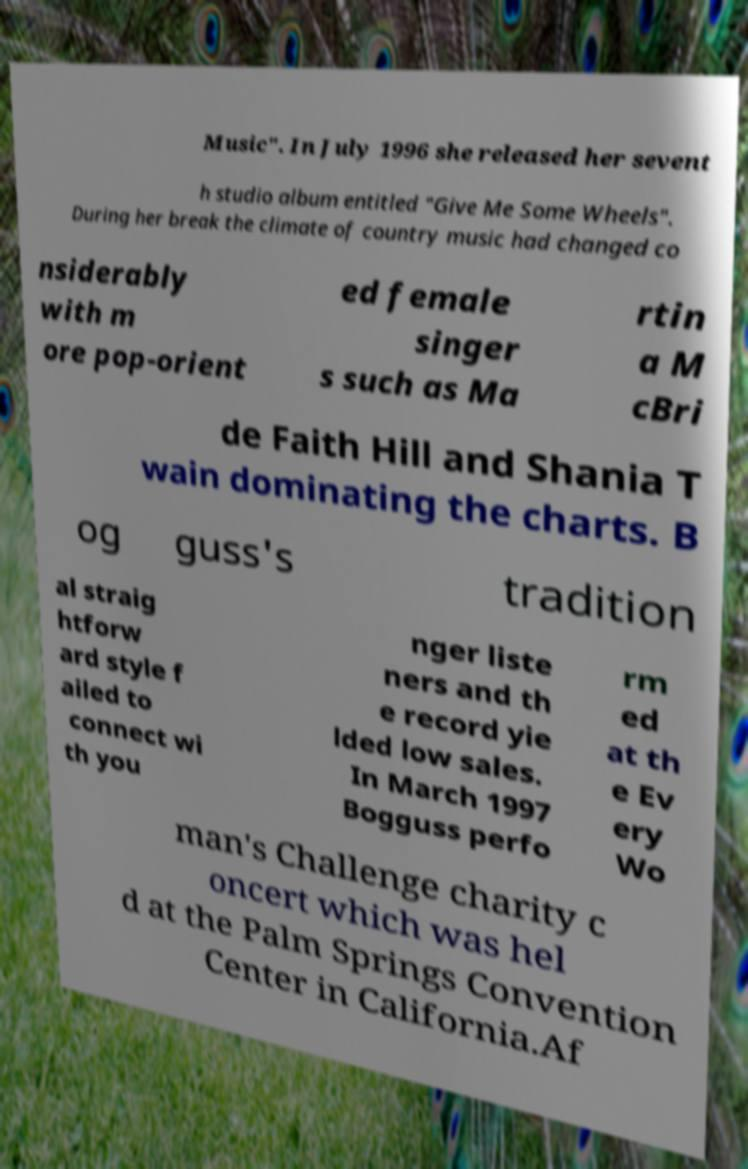Could you assist in decoding the text presented in this image and type it out clearly? Music". In July 1996 she released her sevent h studio album entitled "Give Me Some Wheels". During her break the climate of country music had changed co nsiderably with m ore pop-orient ed female singer s such as Ma rtin a M cBri de Faith Hill and Shania T wain dominating the charts. B og guss's tradition al straig htforw ard style f ailed to connect wi th you nger liste ners and th e record yie lded low sales. In March 1997 Bogguss perfo rm ed at th e Ev ery Wo man's Challenge charity c oncert which was hel d at the Palm Springs Convention Center in California.Af 